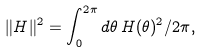Convert formula to latex. <formula><loc_0><loc_0><loc_500><loc_500>\| H \| ^ { 2 } = \int _ { 0 } ^ { 2 \pi } d \theta \, H ( \theta ) ^ { 2 } / 2 \pi ,</formula> 